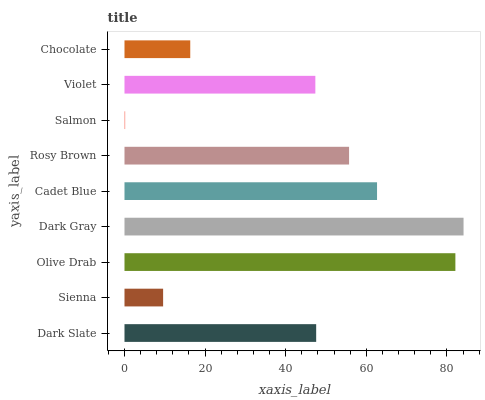Is Salmon the minimum?
Answer yes or no. Yes. Is Dark Gray the maximum?
Answer yes or no. Yes. Is Sienna the minimum?
Answer yes or no. No. Is Sienna the maximum?
Answer yes or no. No. Is Dark Slate greater than Sienna?
Answer yes or no. Yes. Is Sienna less than Dark Slate?
Answer yes or no. Yes. Is Sienna greater than Dark Slate?
Answer yes or no. No. Is Dark Slate less than Sienna?
Answer yes or no. No. Is Dark Slate the high median?
Answer yes or no. Yes. Is Dark Slate the low median?
Answer yes or no. Yes. Is Sienna the high median?
Answer yes or no. No. Is Cadet Blue the low median?
Answer yes or no. No. 